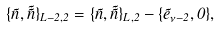Convert formula to latex. <formula><loc_0><loc_0><loc_500><loc_500>\{ \vec { n } , \vec { \tilde { n } } \} _ { L - 2 , 2 } = \{ \vec { n } , \vec { \tilde { n } } \} _ { L , 2 } - \{ \vec { e } _ { \nu - 2 } , 0 \} ,</formula> 